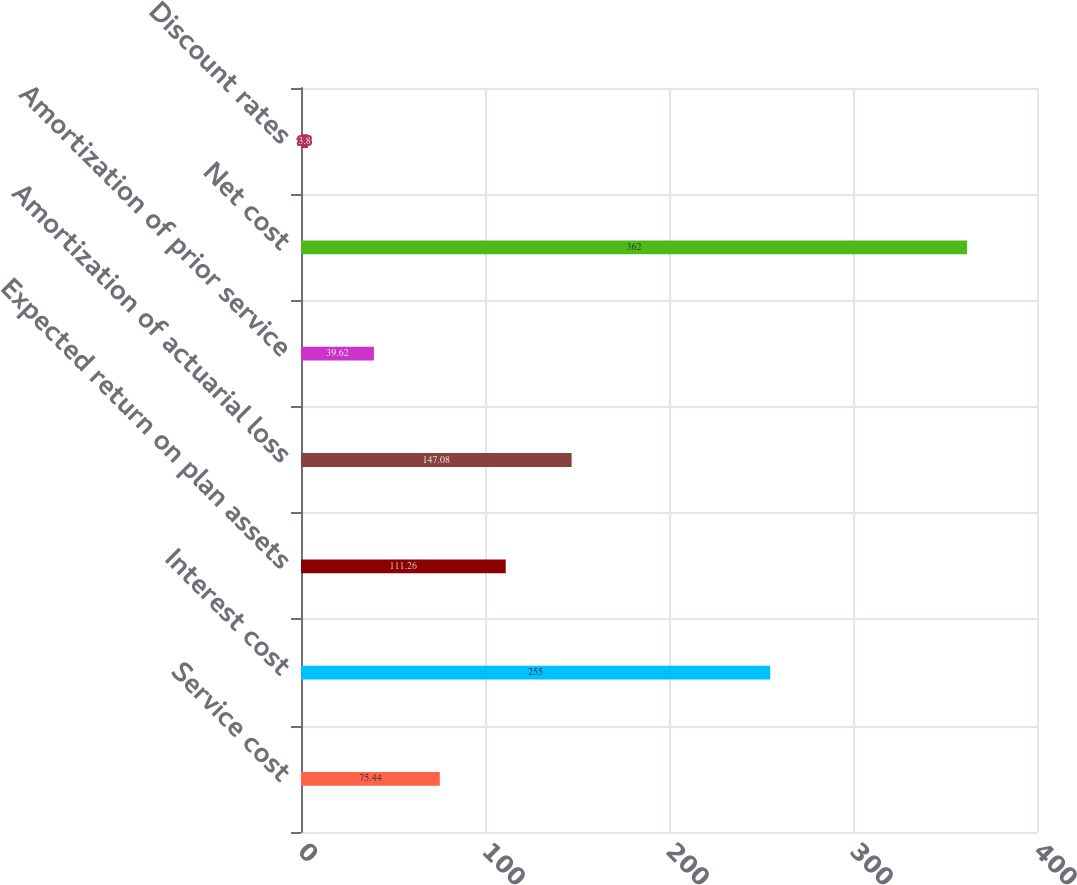Convert chart. <chart><loc_0><loc_0><loc_500><loc_500><bar_chart><fcel>Service cost<fcel>Interest cost<fcel>Expected return on plan assets<fcel>Amortization of actuarial loss<fcel>Amortization of prior service<fcel>Net cost<fcel>Discount rates<nl><fcel>75.44<fcel>255<fcel>111.26<fcel>147.08<fcel>39.62<fcel>362<fcel>3.8<nl></chart> 